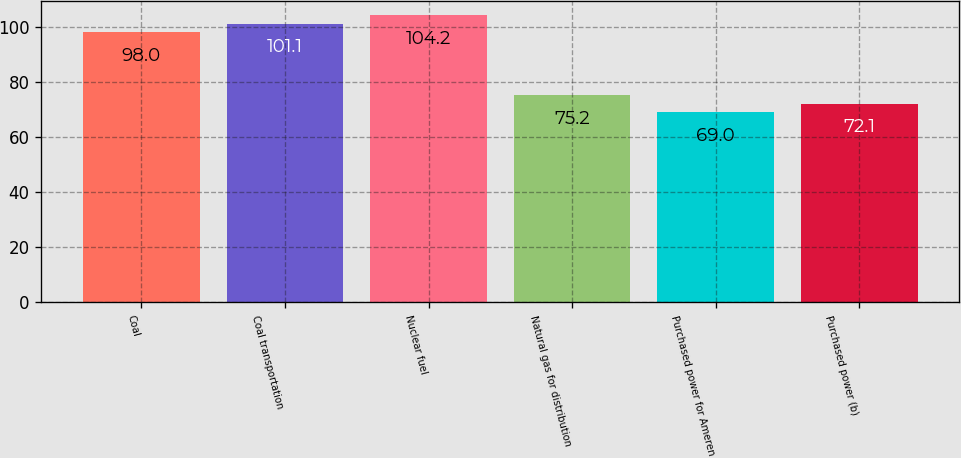<chart> <loc_0><loc_0><loc_500><loc_500><bar_chart><fcel>Coal<fcel>Coal transportation<fcel>Nuclear fuel<fcel>Natural gas for distribution<fcel>Purchased power for Ameren<fcel>Purchased power (b)<nl><fcel>98<fcel>101.1<fcel>104.2<fcel>75.2<fcel>69<fcel>72.1<nl></chart> 